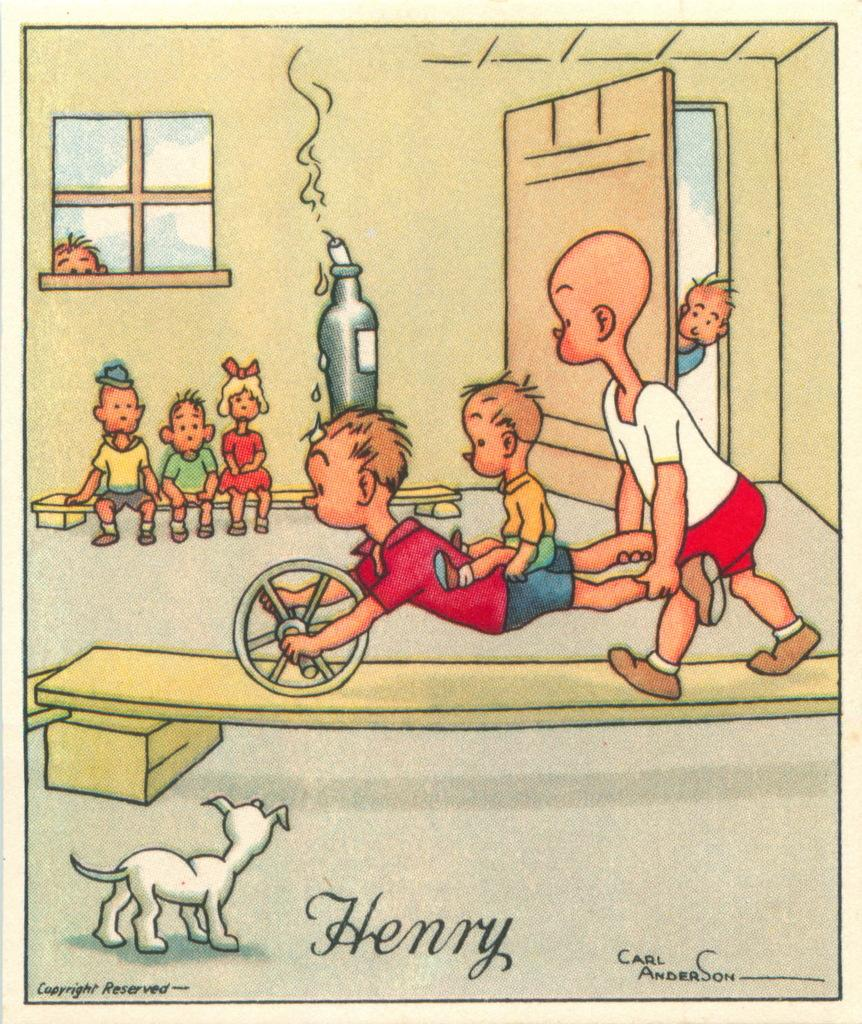What type of image is being described? The image is animated. Where are the kids located in the image? The kids are in a room. What are the kids doing in the image? The kids are performing an activity. What animal is present in the image? There is a dog beside the kids. How do the ants help the kids with their activity in the image? There are no ants present in the image; it features kids and a dog in a room. 